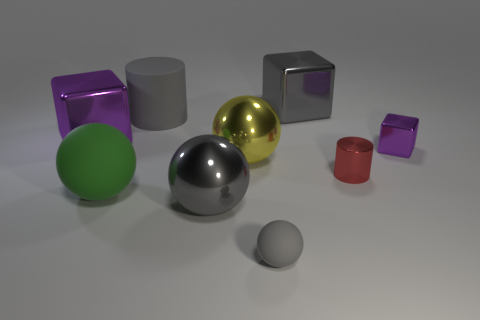There is a tiny shiny object on the left side of the small cube; how many tiny purple shiny cubes are behind it?
Your answer should be very brief. 1. Are there any shiny spheres of the same color as the small matte ball?
Ensure brevity in your answer.  Yes. Do the green rubber object and the red shiny cylinder have the same size?
Offer a terse response. No. Is the color of the matte cylinder the same as the tiny rubber object?
Offer a very short reply. Yes. The green object that is in front of the purple cube that is in front of the big purple metal block is made of what material?
Ensure brevity in your answer.  Rubber. What is the material of the yellow thing that is the same shape as the small gray object?
Offer a terse response. Metal. Is the size of the cylinder left of the red metallic object the same as the yellow shiny thing?
Offer a terse response. Yes. How many shiny things are either blue balls or large gray spheres?
Your answer should be compact. 1. What material is the thing that is in front of the big yellow object and right of the large gray cube?
Provide a short and direct response. Metal. Is the yellow ball made of the same material as the large green thing?
Offer a very short reply. No. 